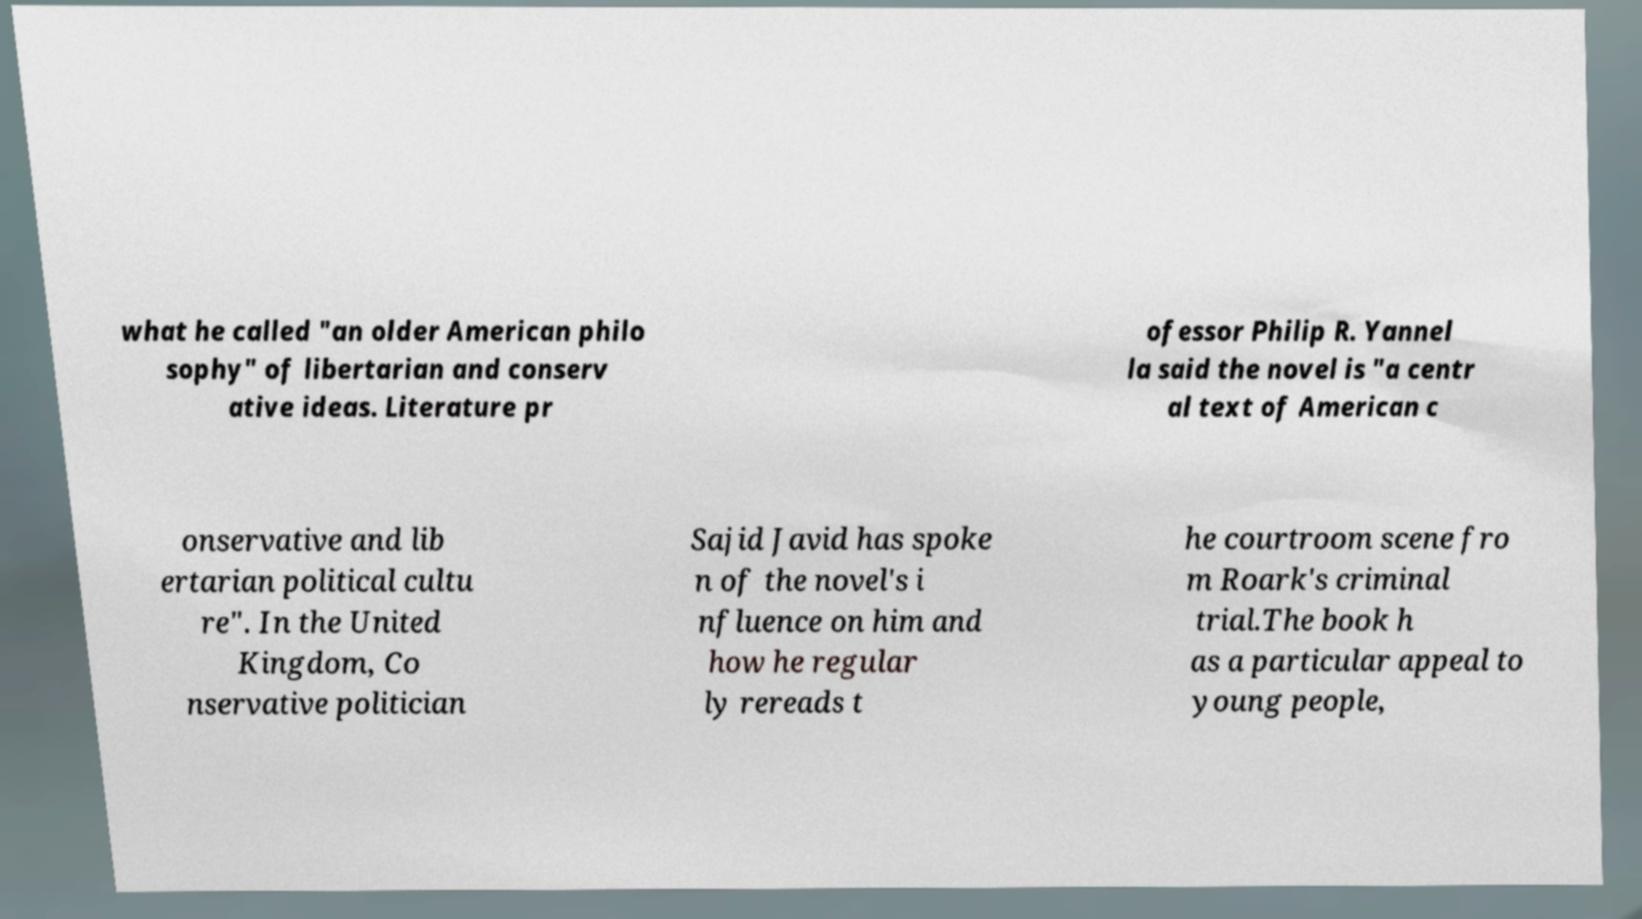Could you assist in decoding the text presented in this image and type it out clearly? what he called "an older American philo sophy" of libertarian and conserv ative ideas. Literature pr ofessor Philip R. Yannel la said the novel is "a centr al text of American c onservative and lib ertarian political cultu re". In the United Kingdom, Co nservative politician Sajid Javid has spoke n of the novel's i nfluence on him and how he regular ly rereads t he courtroom scene fro m Roark's criminal trial.The book h as a particular appeal to young people, 